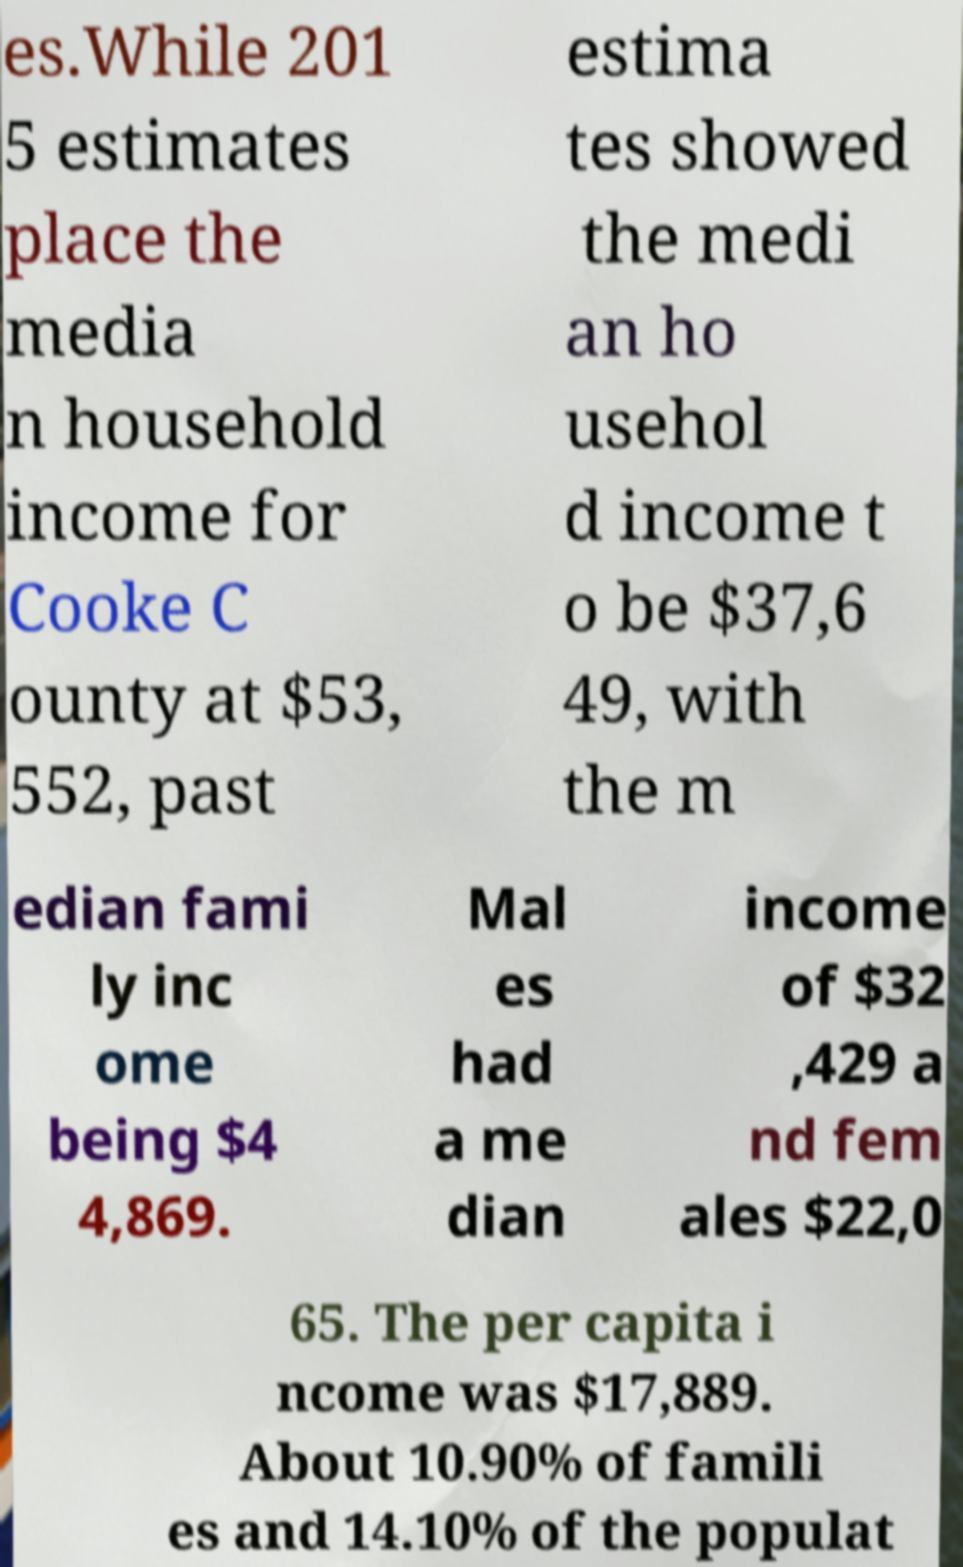Please read and relay the text visible in this image. What does it say? es.While 201 5 estimates place the media n household income for Cooke C ounty at $53, 552, past estima tes showed the medi an ho usehol d income t o be $37,6 49, with the m edian fami ly inc ome being $4 4,869. Mal es had a me dian income of $32 ,429 a nd fem ales $22,0 65. The per capita i ncome was $17,889. About 10.90% of famili es and 14.10% of the populat 